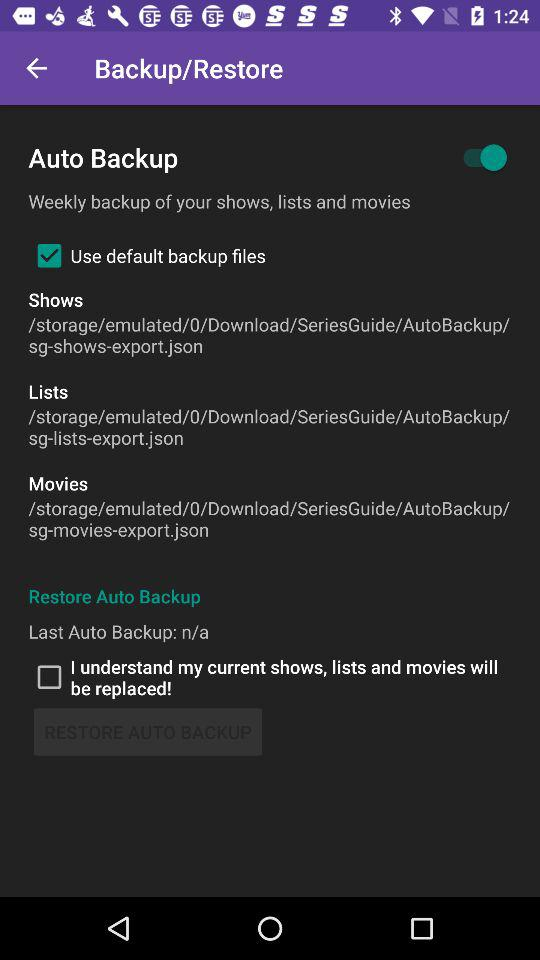What is the status of "Auto Backup"? The status is "on". 